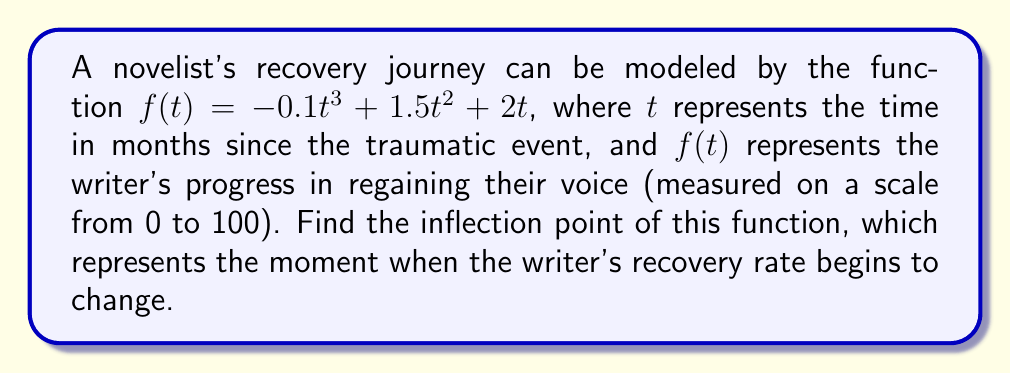Help me with this question. To find the inflection point, we need to follow these steps:

1) First, we need to find the second derivative of the function.

   The first derivative is:
   $$f'(t) = -0.3t^2 + 3t + 2$$

   The second derivative is:
   $$f''(t) = -0.6t + 3$$

2) The inflection point occurs where the second derivative equals zero:

   $$f''(t) = 0$$
   $$-0.6t + 3 = 0$$

3) Solve this equation for $t$:

   $$-0.6t = -3$$
   $$t = 5$$

4) To confirm this is an inflection point, we can check if $f''(t)$ changes sign at $t=5$:

   For $t < 5$, $f''(t) > 0$
   For $t > 5$, $f''(t) < 0$

   This confirms that $t=5$ is indeed an inflection point.

5) To find the $y$-coordinate of the inflection point, we plug $t=5$ into the original function:

   $$f(5) = -0.1(5^3) + 1.5(5^2) + 2(5)$$
   $$= -12.5 + 37.5 + 10$$
   $$= 35$$

Therefore, the inflection point occurs at (5, 35).
Answer: (5, 35) 